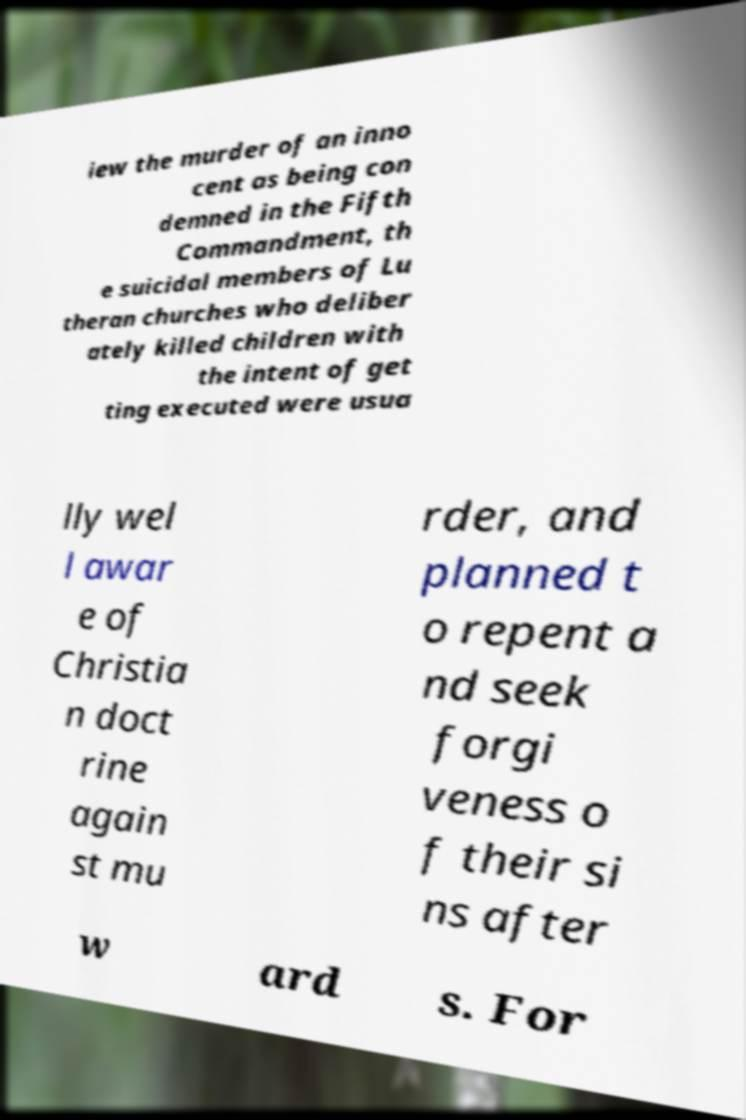Could you assist in decoding the text presented in this image and type it out clearly? iew the murder of an inno cent as being con demned in the Fifth Commandment, th e suicidal members of Lu theran churches who deliber ately killed children with the intent of get ting executed were usua lly wel l awar e of Christia n doct rine again st mu rder, and planned t o repent a nd seek forgi veness o f their si ns after w ard s. For 